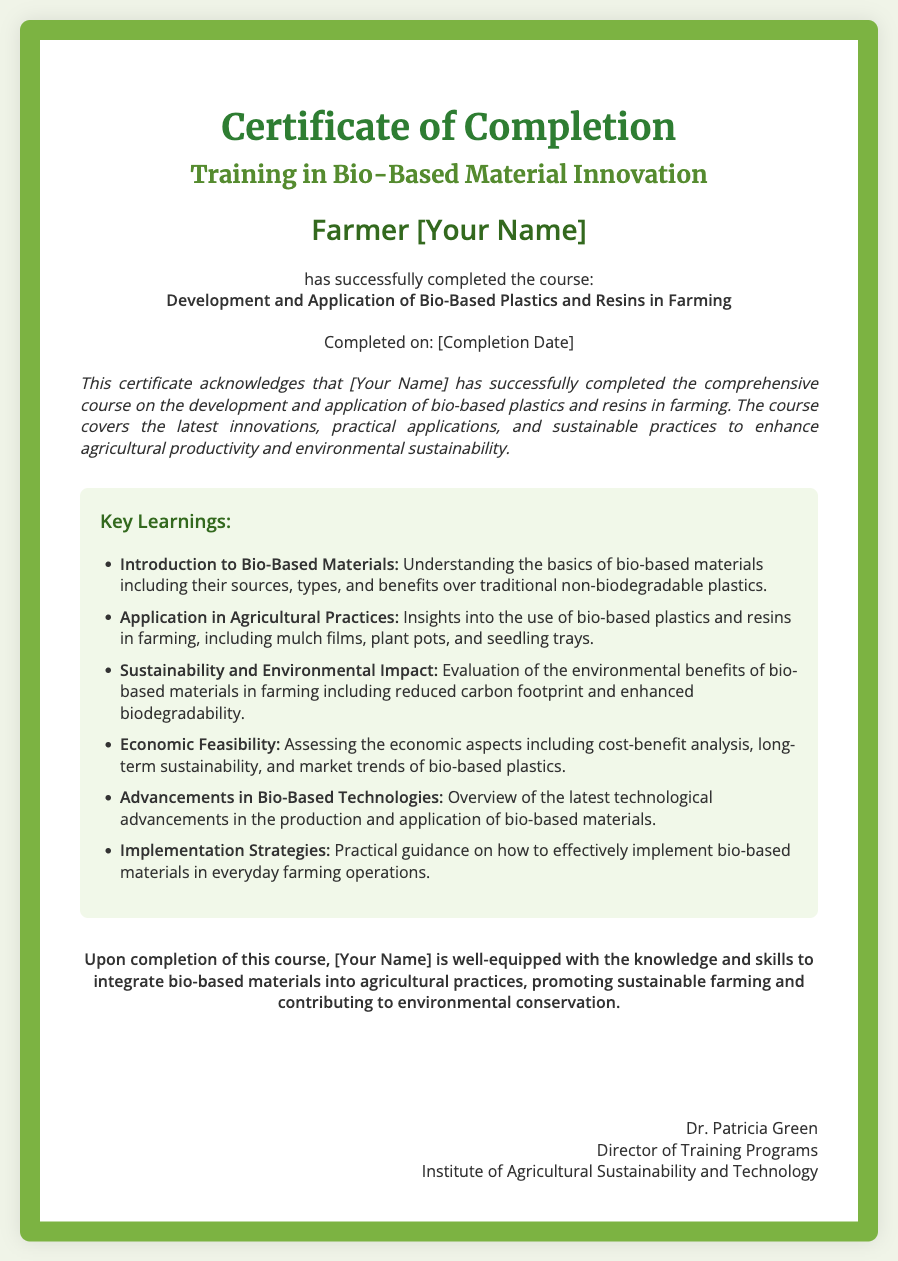What is the title of the certificate? The title of the certificate is presented prominently at the top of the document.
Answer: Certificate of Completion Who is the recipient of the certificate? The recipient's name is highlighted in bold within the document.
Answer: Farmer [Your Name] What course did the recipient complete? The course title is listed in bold within the certificate.
Answer: Development and Application of Bio-Based Plastics and Resins in Farming When was the course completed? The completion date is mentioned in a specified section of the document.
Answer: [Completion Date] What is one key learning related to sustainability mentioned in the document? The document outlines sustainable practices and innovations in bio-based materials.
Answer: Evaluation of the environmental benefits Who signed the certificate? The signature section identifies the individual approving the document.
Answer: Dr. Patricia Green What color is the border of the certificate? The border color is described within the styling of the document.
Answer: Green What type of materials does the course focus on? The course content is specifically targeted towards a certain type of material.
Answer: Bio-Based Plastics and Resins How many key learnings are listed in the document? The list provides insights into several specific concepts presented in the course.
Answer: Six 